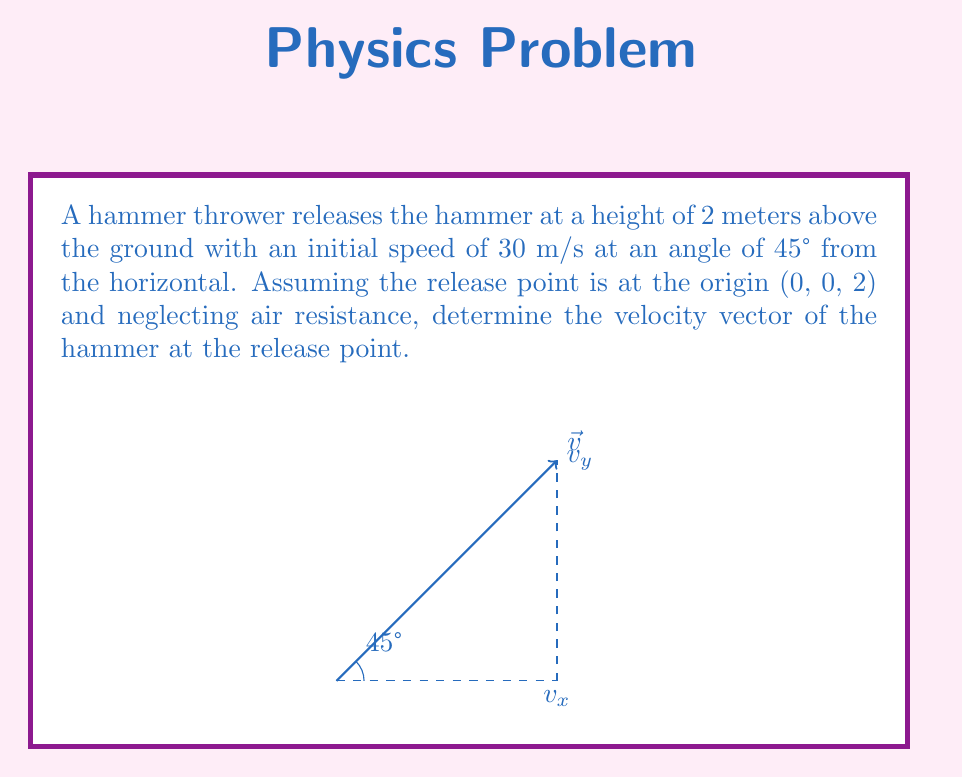Can you solve this math problem? To determine the velocity vector of the hammer at the release point, we need to calculate its components in the x, y, and z directions.

Step 1: Decompose the initial velocity into its horizontal and vertical components.
Let $\vec{v}$ be the velocity vector, with magnitude 30 m/s and angle 45° from the horizontal.

Horizontal component (x-direction):
$$v_x = v \cos \theta = 30 \cos 45° = 30 \cdot \frac{\sqrt{2}}{2} \approx 21.21 \text{ m/s}$$

Vertical component (y-direction):
$$v_y = v \sin \theta = 30 \sin 45° = 30 \cdot \frac{\sqrt{2}}{2} \approx 21.21 \text{ m/s}$$

Step 2: Determine the z-component of velocity.
Since the hammer is released at a constant height and not moving vertically at the release point, the z-component of velocity is zero.
$$v_z = 0 \text{ m/s}$$

Step 3: Combine the components to form the velocity vector.
The velocity vector $\vec{v}$ at the release point is:
$$\vec{v} = \langle v_x, v_y, v_z \rangle = \langle 30\frac{\sqrt{2}}{2}, 30\frac{\sqrt{2}}{2}, 0 \rangle$$
Answer: $\vec{v} = \langle 15\sqrt{2}, 15\sqrt{2}, 0 \rangle$ m/s 